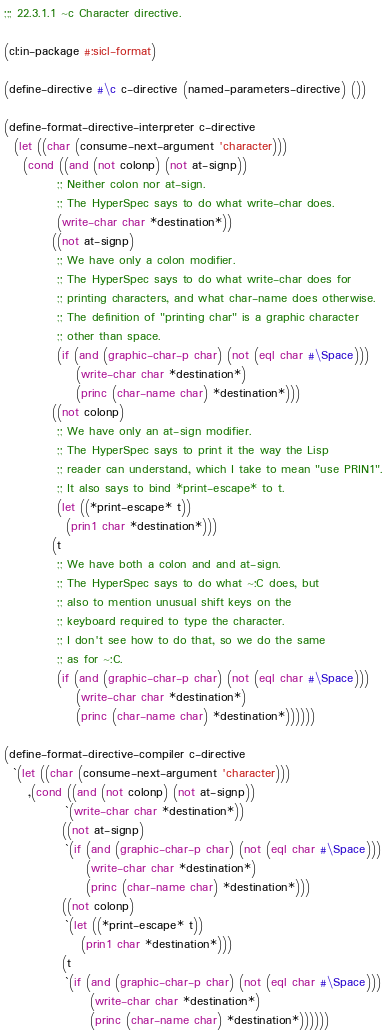<code> <loc_0><loc_0><loc_500><loc_500><_Lisp_>;;; 22.3.1.1 ~c Character directive.

(cl:in-package #:sicl-format)

(define-directive #\c c-directive (named-parameters-directive) ())

(define-format-directive-interpreter c-directive
  (let ((char (consume-next-argument 'character)))
    (cond ((and (not colonp) (not at-signp))
           ;; Neither colon nor at-sign.
           ;; The HyperSpec says to do what write-char does.
           (write-char char *destination*))
          ((not at-signp)
           ;; We have only a colon modifier.
           ;; The HyperSpec says to do what write-char does for
           ;; printing characters, and what char-name does otherwise.
           ;; The definition of "printing char" is a graphic character
           ;; other than space.
           (if (and (graphic-char-p char) (not (eql char #\Space)))
               (write-char char *destination*)
               (princ (char-name char) *destination*)))
          ((not colonp)
           ;; We have only an at-sign modifier.
           ;; The HyperSpec says to print it the way the Lisp
           ;; reader can understand, which I take to mean "use PRIN1".
           ;; It also says to bind *print-escape* to t.
           (let ((*print-escape* t))
             (prin1 char *destination*)))
          (t
           ;; We have both a colon and and at-sign.
           ;; The HyperSpec says to do what ~:C does, but
           ;; also to mention unusual shift keys on the
           ;; keyboard required to type the character.
           ;; I don't see how to do that, so we do the same
           ;; as for ~:C.
           (if (and (graphic-char-p char) (not (eql char #\Space)))
               (write-char char *destination*)
               (princ (char-name char) *destination*))))))

(define-format-directive-compiler c-directive
  `(let ((char (consume-next-argument 'character)))
     ,(cond ((and (not colonp) (not at-signp))
             `(write-char char *destination*))
            ((not at-signp)
             `(if (and (graphic-char-p char) (not (eql char #\Space)))
                 (write-char char *destination*)
                 (princ (char-name char) *destination*)))
            ((not colonp)
             `(let ((*print-escape* t))
                (prin1 char *destination*)))
            (t
             `(if (and (graphic-char-p char) (not (eql char #\Space)))
                  (write-char char *destination*)
                  (princ (char-name char) *destination*))))))
</code> 